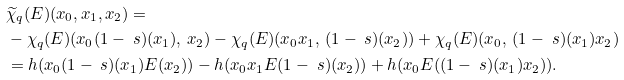Convert formula to latex. <formula><loc_0><loc_0><loc_500><loc_500>& \widetilde { \chi } _ { q } ( E ) ( x _ { 0 } , x _ { 1 } , x _ { 2 } ) = \\ & - \chi _ { q } ( E ) ( x _ { 0 } ( 1 - \ s ) ( x _ { 1 } ) , \, x _ { 2 } ) - \chi _ { q } ( E ) ( x _ { 0 } x _ { 1 } , \, ( 1 - \ s ) ( x _ { 2 } ) ) + \chi _ { q } ( E ) ( x _ { 0 } , \, ( 1 - \ s ) ( x _ { 1 } ) x _ { 2 } ) \\ & = h ( x _ { 0 } ( 1 - \ s ) ( x _ { 1 } ) E ( x _ { 2 } ) ) - h ( x _ { 0 } x _ { 1 } E ( 1 - \ s ) ( x _ { 2 } ) ) + h ( x _ { 0 } E ( ( 1 - \ s ) ( x _ { 1 } ) x _ { 2 } ) ) . \\</formula> 